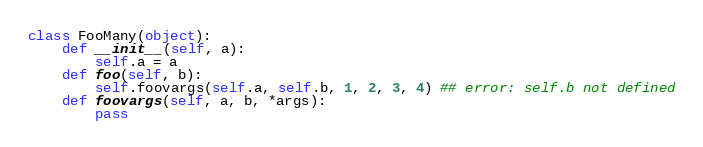<code> <loc_0><loc_0><loc_500><loc_500><_Python_>class FooMany(object):
	def __init__(self, a):
		self.a = a
	def foo(self, b):
		self.foovargs(self.a, self.b, 1, 2, 3, 4) ## error: self.b not defined
	def foovargs(self, a, b, *args):
		pass



</code> 